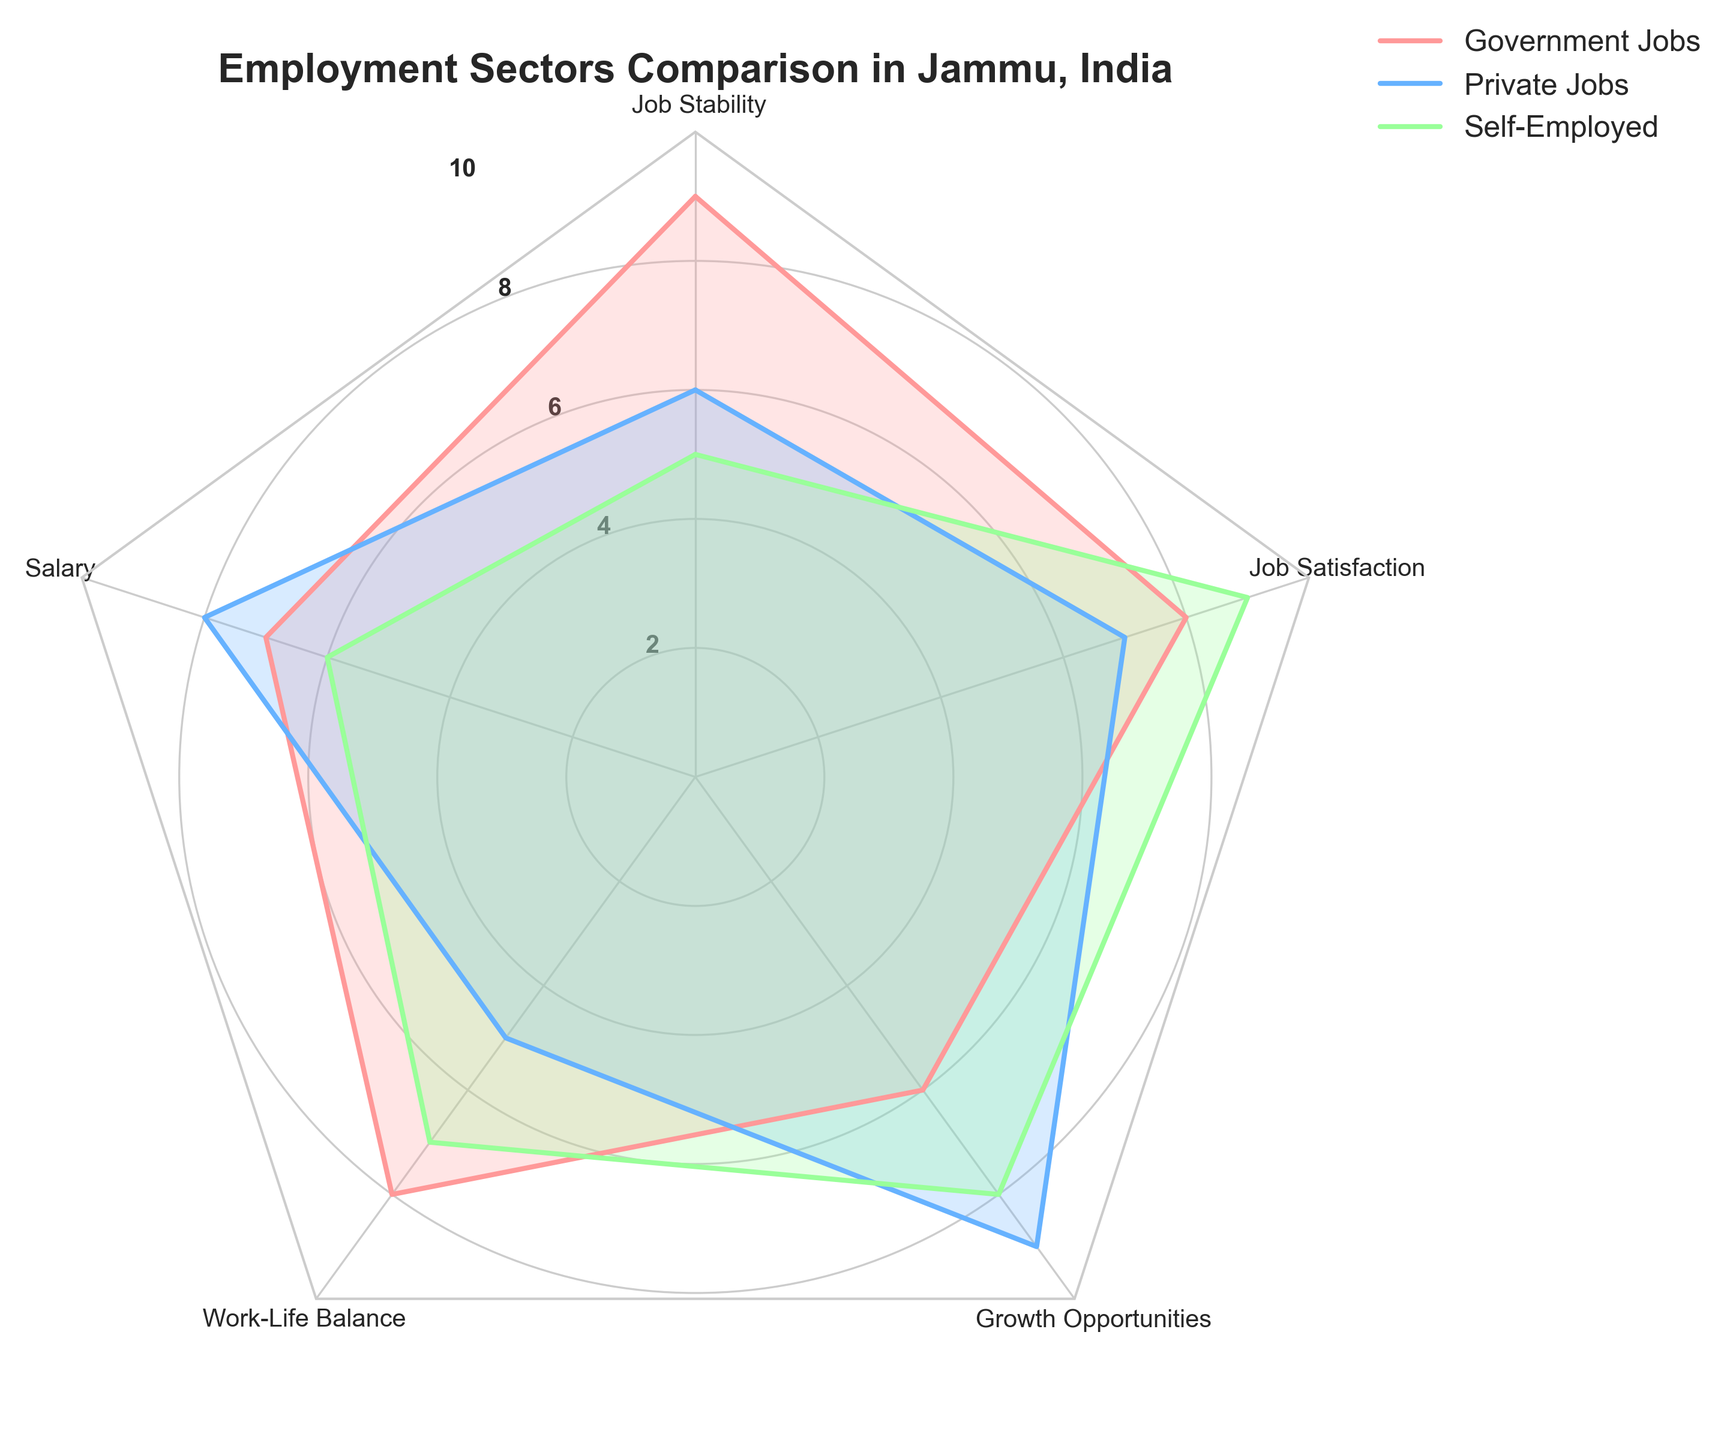What is the title of the radar chart? The title is displayed at the top of the radar chart and provides a summary of what the chart represents.
Answer: Employment Sectors Comparison in Jammu, India What are the sectors compared in the radar chart? The sectors compared are commonly labeled on the legend or directly within the chart.
Answer: Government Jobs, Private Jobs, Self-Employed Which employment sector has the highest job stability? By comparing the values for job stability on the radar chart, one can see which sector has the highest rating.
Answer: Government Jobs Which sector has the lowest score for salary? Check the plotted values corresponding to the "Salary" category and identify the sector with the smallest value.
Answer: Self-Employed How many variables/categories are considered in the radar chart? The number of variables can be counted by looking at the number of labels around the radar chart.
Answer: 5 Which two categories have the highest scores for Self-Employed sector? Check the plotted values for the Self-Employed sector and identify the two highest scores.
Answer: Job Satisfaction and Growth Opportunities What is the difference in job satisfaction scores between Government Jobs and Private Jobs? Subtract the job satisfaction score of Private Jobs from that of Government Jobs.
Answer: 1 Which employment sector provides the best work-life balance? By comparing the "Work-Life Balance" values across sectors, identify the highest one.
Answer: Government Jobs Which sector has the greatest variance in scores across all categories? Analyze the spread of the scores for each sector to determine which has the widest range.
Answer: Self-Employed Which sector ranks highest for growth opportunities? Look at the values for the "Growth Opportunities" category and identify the highest score.
Answer: Private Jobs 